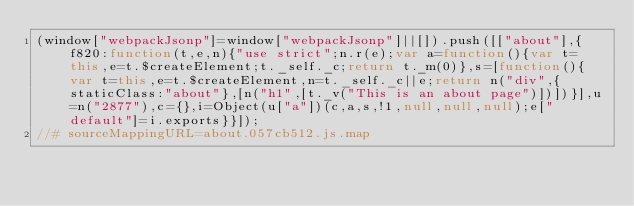<code> <loc_0><loc_0><loc_500><loc_500><_JavaScript_>(window["webpackJsonp"]=window["webpackJsonp"]||[]).push([["about"],{f820:function(t,e,n){"use strict";n.r(e);var a=function(){var t=this,e=t.$createElement;t._self._c;return t._m(0)},s=[function(){var t=this,e=t.$createElement,n=t._self._c||e;return n("div",{staticClass:"about"},[n("h1",[t._v("This is an about page")])])}],u=n("2877"),c={},i=Object(u["a"])(c,a,s,!1,null,null,null);e["default"]=i.exports}}]);
//# sourceMappingURL=about.057cb512.js.map</code> 